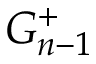<formula> <loc_0><loc_0><loc_500><loc_500>G _ { n - 1 } ^ { + }</formula> 